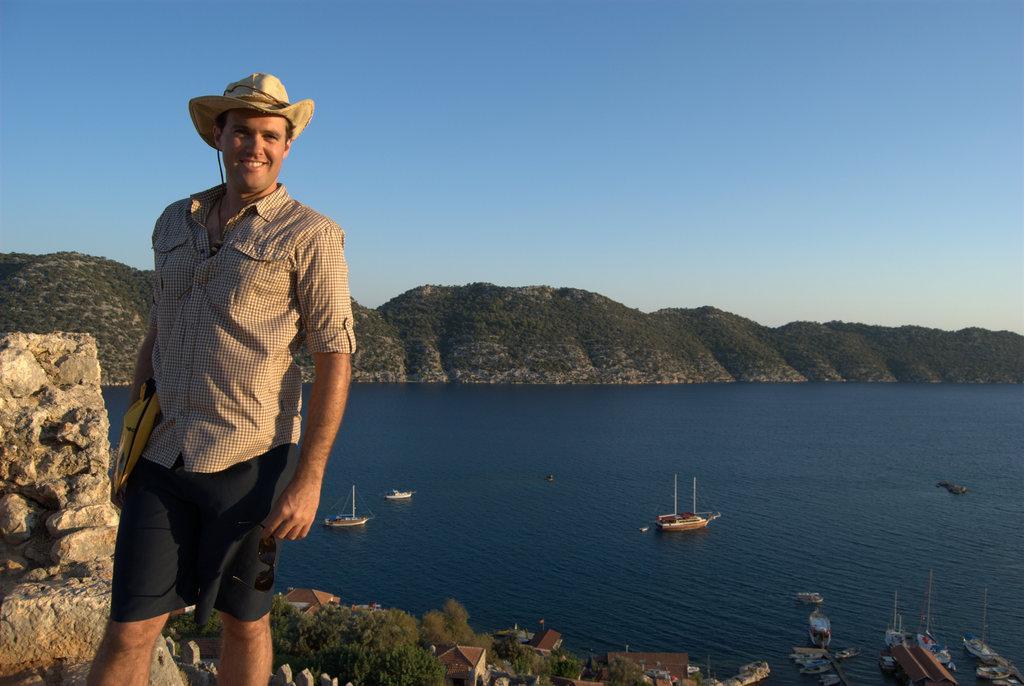Describe this image in one or two sentences. In this picture I can observe a person standing on the left side. He is wearing a hat on his head. He is smiling. I can observe some boats floating on the water. There is a river. In the background there are some hills and a sky. 